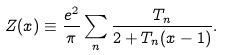<formula> <loc_0><loc_0><loc_500><loc_500>Z ( x ) \equiv \frac { e ^ { 2 } } { \pi } \sum _ { n } \frac { T _ { n } } { 2 + T _ { n } ( x - 1 ) } .</formula> 